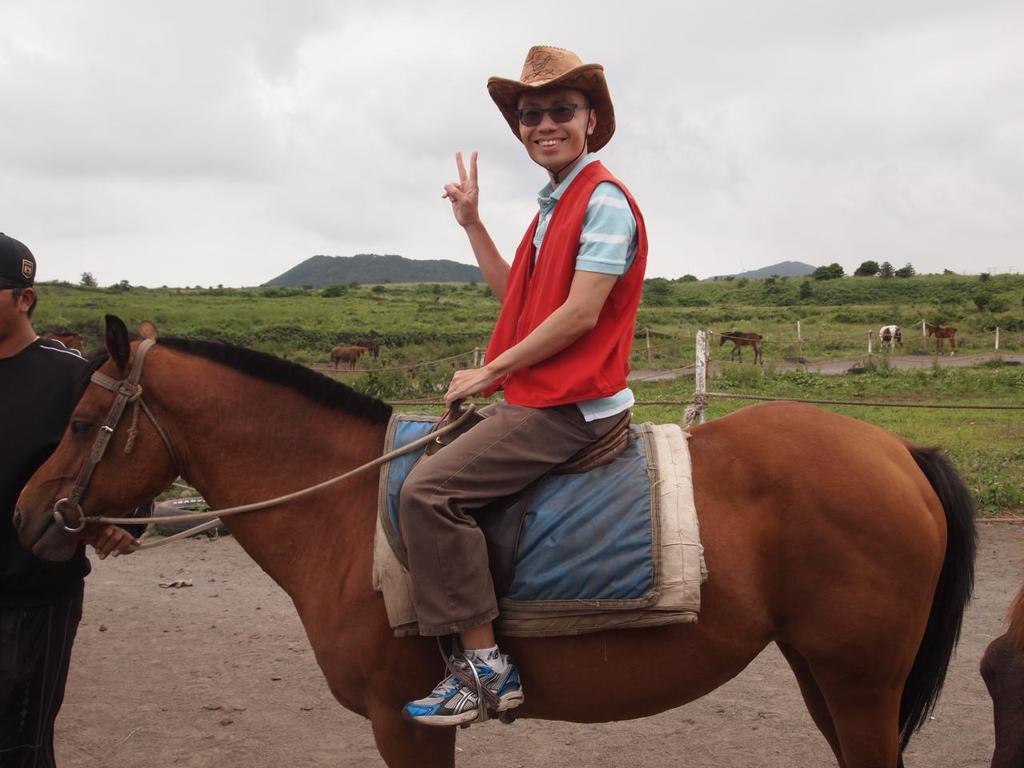What is the man in the image doing? The man is sitting on a horse in the image. What is the man's facial expression? The man is smiling. Who else is present in the image? There is a person standing on the left side of the image. What can be seen in the background of the image? There is grass, a hill, and the sky visible in the background of the image. What is the condition of the sky in the image? The sky is full of clouds in the image. What type of sheet is covering the horse in the image? There is no sheet covering the horse in the image; the horse is not covered. What is inside the box that is visible in the image? There is no box present in the image. 